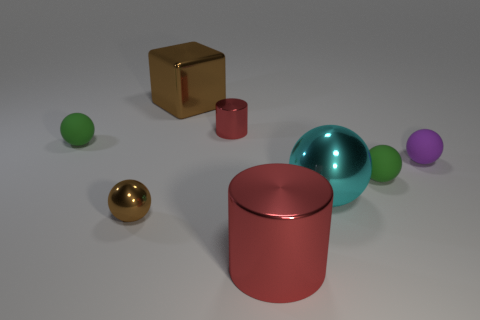Does the small metallic ball have the same color as the large cylinder?
Give a very brief answer. No. How big is the green ball that is to the right of the tiny green rubber sphere that is left of the small red cylinder?
Ensure brevity in your answer.  Small. Is the large thing behind the cyan metal object made of the same material as the brown thing in front of the tiny metal cylinder?
Your answer should be compact. Yes. There is a small matte sphere left of the large brown metal block; does it have the same color as the large sphere?
Your answer should be very brief. No. What number of small green things are to the right of the small purple thing?
Give a very brief answer. 0. Do the tiny red cylinder and the green object that is to the right of the tiny red metallic thing have the same material?
Offer a very short reply. No. There is a cyan sphere that is the same material as the big brown cube; what size is it?
Make the answer very short. Large. Is the number of tiny purple balls that are to the left of the tiny brown metal ball greater than the number of small cylinders that are on the left side of the large red metallic thing?
Keep it short and to the point. No. Is there another thing of the same shape as the cyan shiny object?
Provide a short and direct response. Yes. Does the red metal cylinder that is behind the cyan metal ball have the same size as the big brown metallic block?
Provide a short and direct response. No. 